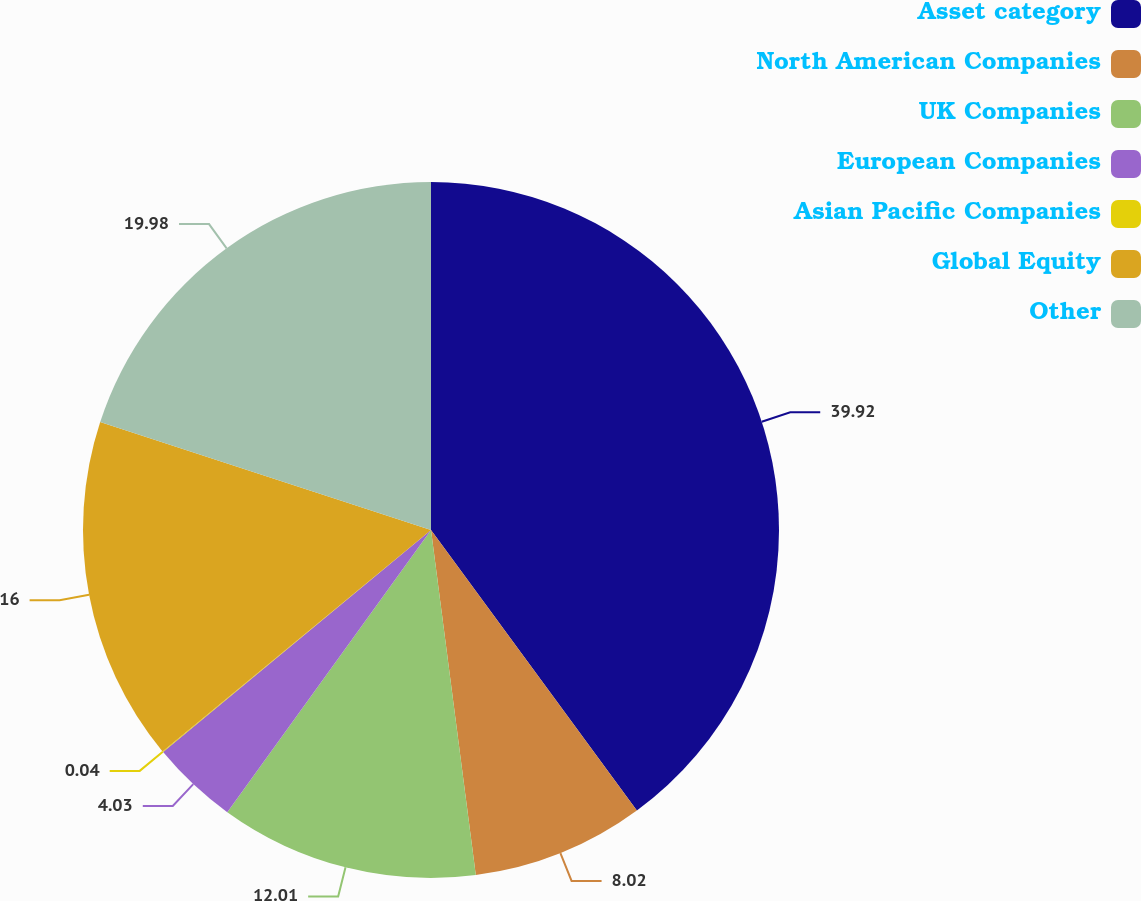Convert chart. <chart><loc_0><loc_0><loc_500><loc_500><pie_chart><fcel>Asset category<fcel>North American Companies<fcel>UK Companies<fcel>European Companies<fcel>Asian Pacific Companies<fcel>Global Equity<fcel>Other<nl><fcel>39.93%<fcel>8.02%<fcel>12.01%<fcel>4.03%<fcel>0.04%<fcel>16.0%<fcel>19.98%<nl></chart> 